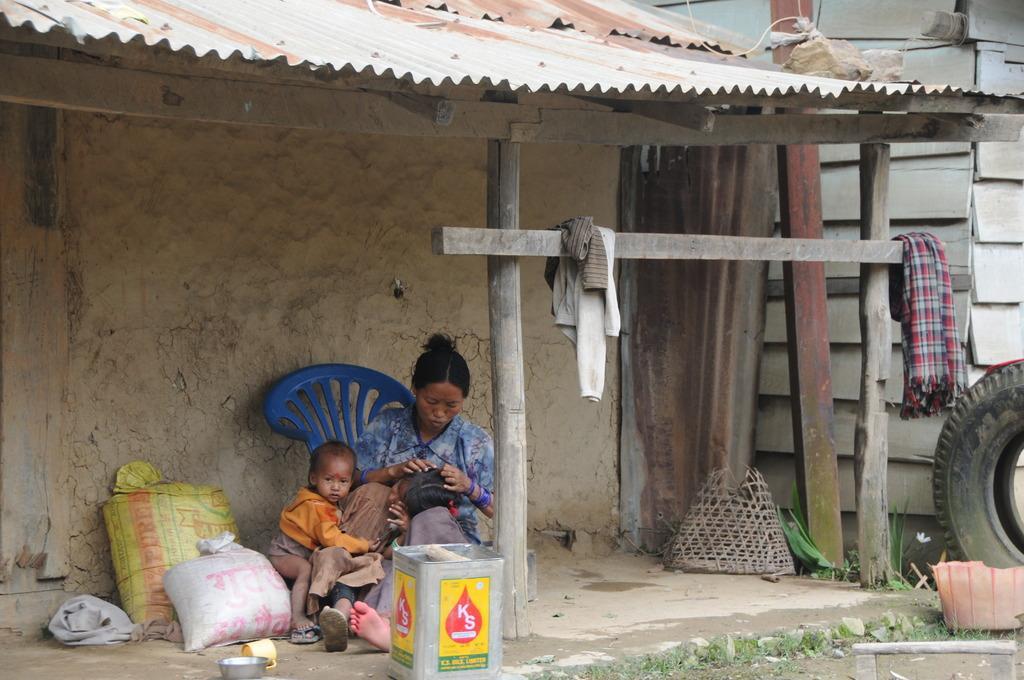Could you give a brief overview of what you see in this image? In this image I can see three people sitting under the shed. To the side of these people I can see the bags, chair and the can. I can see few clothes on the wooden pole. To the right I can see the tyre and the grass. 